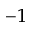Convert formula to latex. <formula><loc_0><loc_0><loc_500><loc_500>^ { - 1 }</formula> 